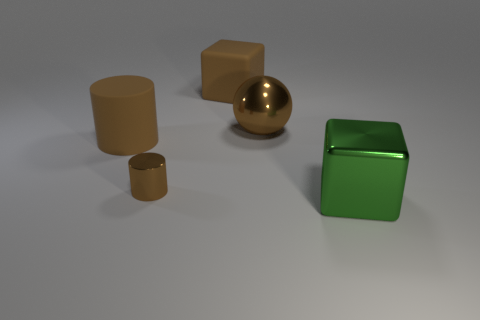Add 5 tiny cylinders. How many objects exist? 10 Subtract all balls. How many objects are left? 4 Subtract all green cubes. How many cubes are left? 1 Subtract 0 red cubes. How many objects are left? 5 Subtract all yellow cylinders. Subtract all purple spheres. How many cylinders are left? 2 Subtract all small brown metal cylinders. Subtract all big balls. How many objects are left? 3 Add 2 big brown metallic balls. How many big brown metallic balls are left? 3 Add 2 big rubber cylinders. How many big rubber cylinders exist? 3 